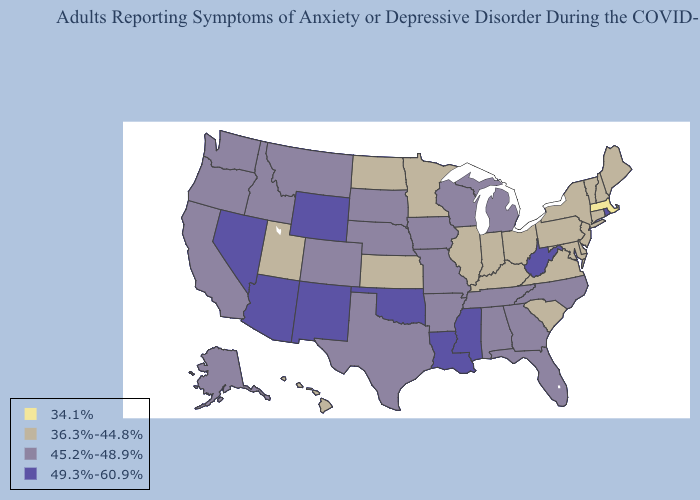Name the states that have a value in the range 45.2%-48.9%?
Short answer required. Alabama, Alaska, Arkansas, California, Colorado, Florida, Georgia, Idaho, Iowa, Michigan, Missouri, Montana, Nebraska, North Carolina, Oregon, South Dakota, Tennessee, Texas, Washington, Wisconsin. Among the states that border Florida , which have the highest value?
Quick response, please. Alabama, Georgia. What is the highest value in the USA?
Short answer required. 49.3%-60.9%. Does Florida have a higher value than North Dakota?
Quick response, please. Yes. Does Maine have the highest value in the USA?
Concise answer only. No. What is the lowest value in states that border Iowa?
Keep it brief. 36.3%-44.8%. What is the value of Kansas?
Answer briefly. 36.3%-44.8%. Which states have the highest value in the USA?
Write a very short answer. Arizona, Louisiana, Mississippi, Nevada, New Mexico, Oklahoma, Rhode Island, West Virginia, Wyoming. Does Louisiana have the highest value in the USA?
Quick response, please. Yes. What is the value of Tennessee?
Keep it brief. 45.2%-48.9%. What is the highest value in the USA?
Write a very short answer. 49.3%-60.9%. Name the states that have a value in the range 34.1%?
Be succinct. Massachusetts. Which states have the lowest value in the Northeast?
Be succinct. Massachusetts. Name the states that have a value in the range 49.3%-60.9%?
Give a very brief answer. Arizona, Louisiana, Mississippi, Nevada, New Mexico, Oklahoma, Rhode Island, West Virginia, Wyoming. 